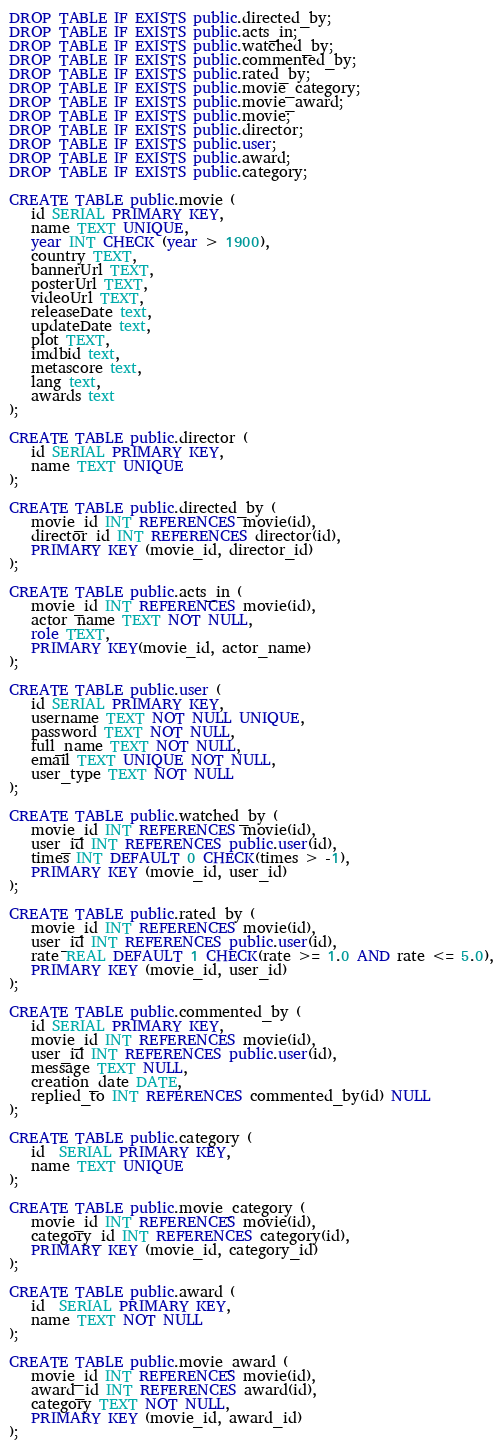<code> <loc_0><loc_0><loc_500><loc_500><_SQL_>DROP TABLE IF EXISTS public.directed_by;
DROP TABLE IF EXISTS public.acts_in;
DROP TABLE IF EXISTS public.watched_by;
DROP TABLE IF EXISTS public.commented_by;
DROP TABLE IF EXISTS public.rated_by;
DROP TABLE IF EXISTS public.movie_category;
DROP TABLE IF EXISTS public.movie_award;
DROP TABLE IF EXISTS public.movie;
DROP TABLE IF EXISTS public.director;
DROP TABLE IF EXISTS public.user;
DROP TABLE IF EXISTS public.award;
DROP TABLE IF EXISTS public.category;

CREATE TABLE public.movie (
   id SERIAL PRIMARY KEY,
   name TEXT UNIQUE,
   year INT CHECK (year > 1900),
   country TEXT,
   bannerUrl TEXT,
   posterUrl TEXT,
   videoUrl TEXT,
   releaseDate text,
   updateDate text,
   plot TEXT,
   imdbid text,
   metascore text,
   lang text,
   awards text
);

CREATE TABLE public.director (
   id SERIAL PRIMARY KEY,
   name TEXT UNIQUE
);

CREATE TABLE public.directed_by (
   movie_id INT REFERENCES movie(id),
   director_id INT REFERENCES director(id),
   PRIMARY KEY (movie_id, director_id)
);

CREATE TABLE public.acts_in (
   movie_id INT REFERENCES movie(id),
   actor_name TEXT NOT NULL,
   role TEXT,
   PRIMARY KEY(movie_id, actor_name)
);

CREATE TABLE public.user (
   id SERIAL PRIMARY KEY,
   username TEXT NOT NULL UNIQUE,
   password TEXT NOT NULL,
   full_name TEXT NOT NULL,
   email TEXT UNIQUE NOT NULL,
   user_type TEXT NOT NULL
);

CREATE TABLE public.watched_by (
   movie_id INT REFERENCES movie(id),
   user_id INT REFERENCES public.user(id),
   times INT DEFAULT 0 CHECK(times > -1),
   PRIMARY KEY (movie_id, user_id)
);

CREATE TABLE public.rated_by (
   movie_id INT REFERENCES movie(id),
   user_id INT REFERENCES public.user(id),
   rate REAL DEFAULT 1 CHECK(rate >= 1.0 AND rate <= 5.0),
   PRIMARY KEY (movie_id, user_id)
);

CREATE TABLE public.commented_by (
   id SERIAL PRIMARY KEY,
   movie_id INT REFERENCES movie(id),
   user_id INT REFERENCES public.user(id),
   message TEXT NULL,
   creation_date DATE,
   replied_to INT REFERENCES commented_by(id) NULL
);

CREATE TABLE public.category (
   id  SERIAL PRIMARY KEY,
   name TEXT UNIQUE
);

CREATE TABLE public.movie_category (
   movie_id INT REFERENCES movie(id),
   category_id INT REFERENCES category(id),
   PRIMARY KEY (movie_id, category_id)
);

CREATE TABLE public.award (
   id  SERIAL PRIMARY KEY,
   name TEXT NOT NULL
);

CREATE TABLE public.movie_award (
   movie_id INT REFERENCES movie(id),
   award_id INT REFERENCES award(id),
   category TEXT NOT NULL,
   PRIMARY KEY (movie_id, award_id)
);

</code> 